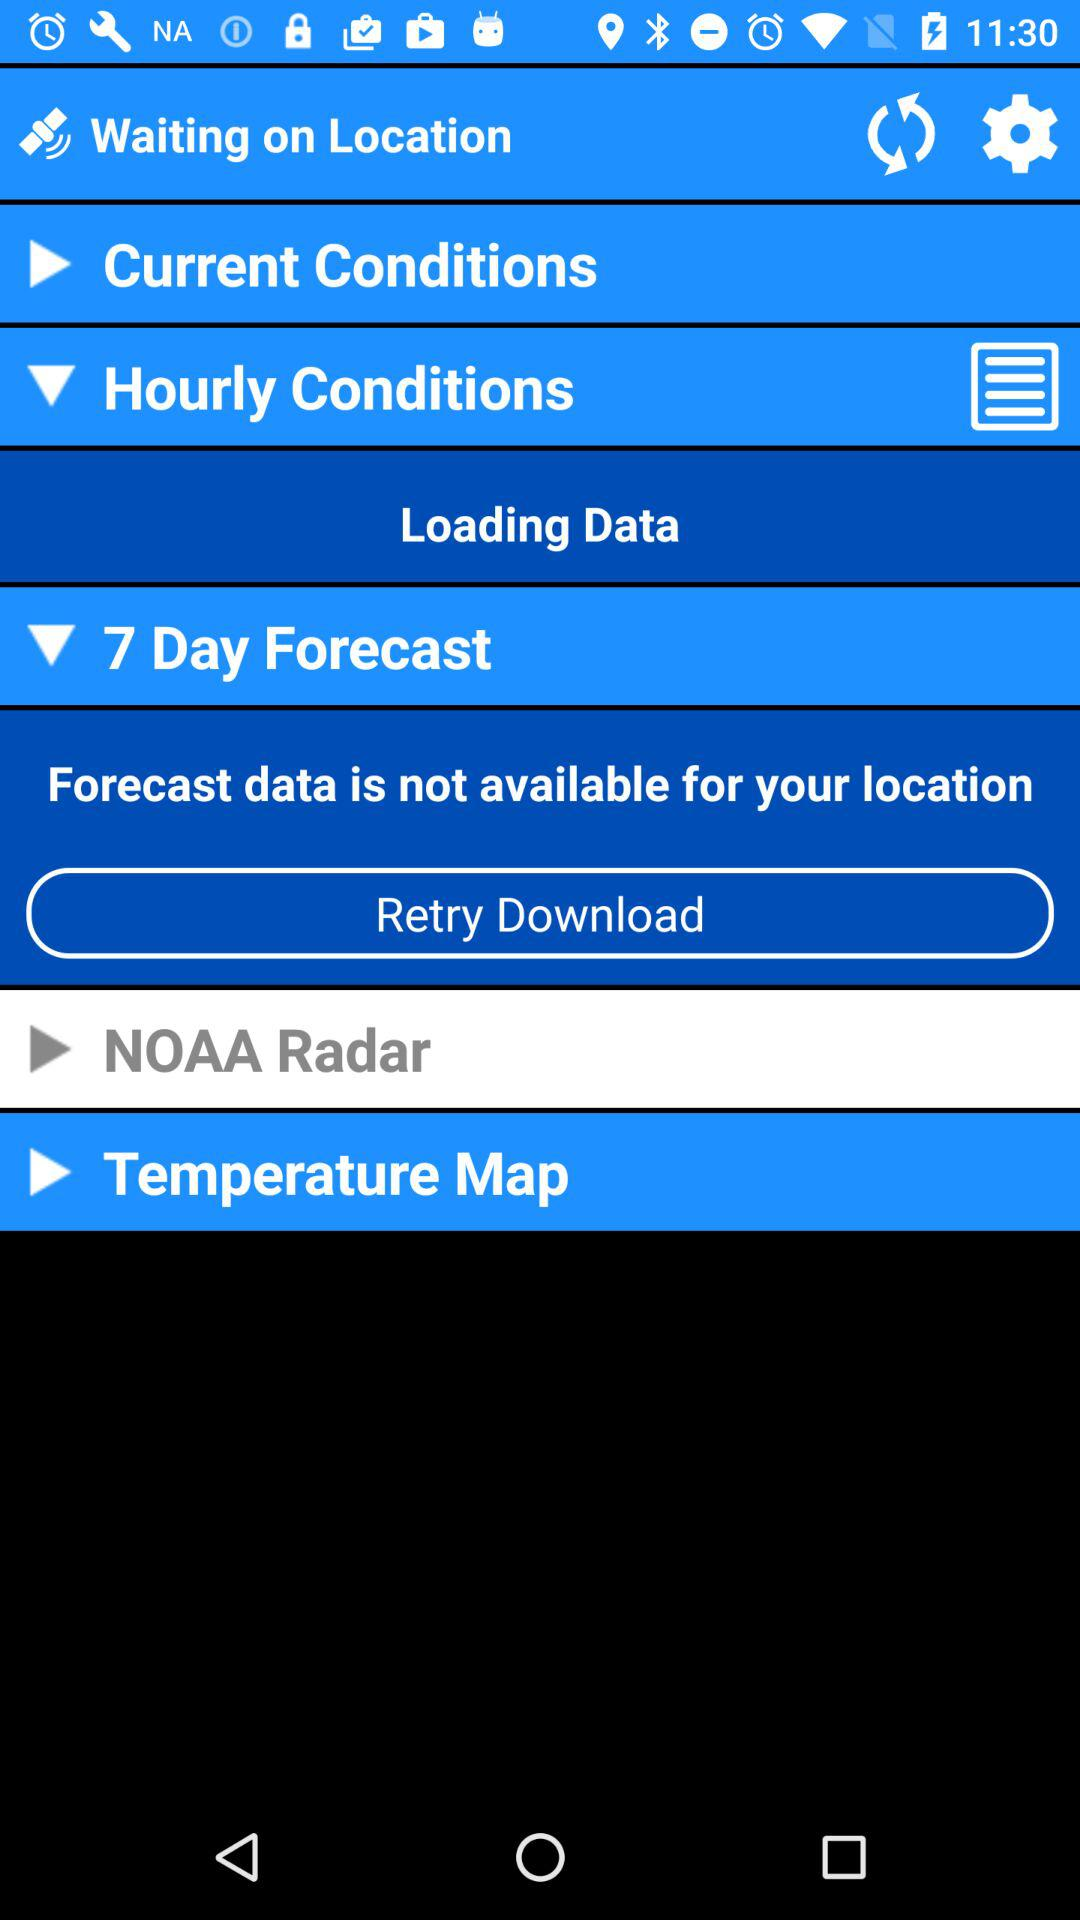What is the selected number of days for the forecast? The selected number of days for the forecast is 7. 